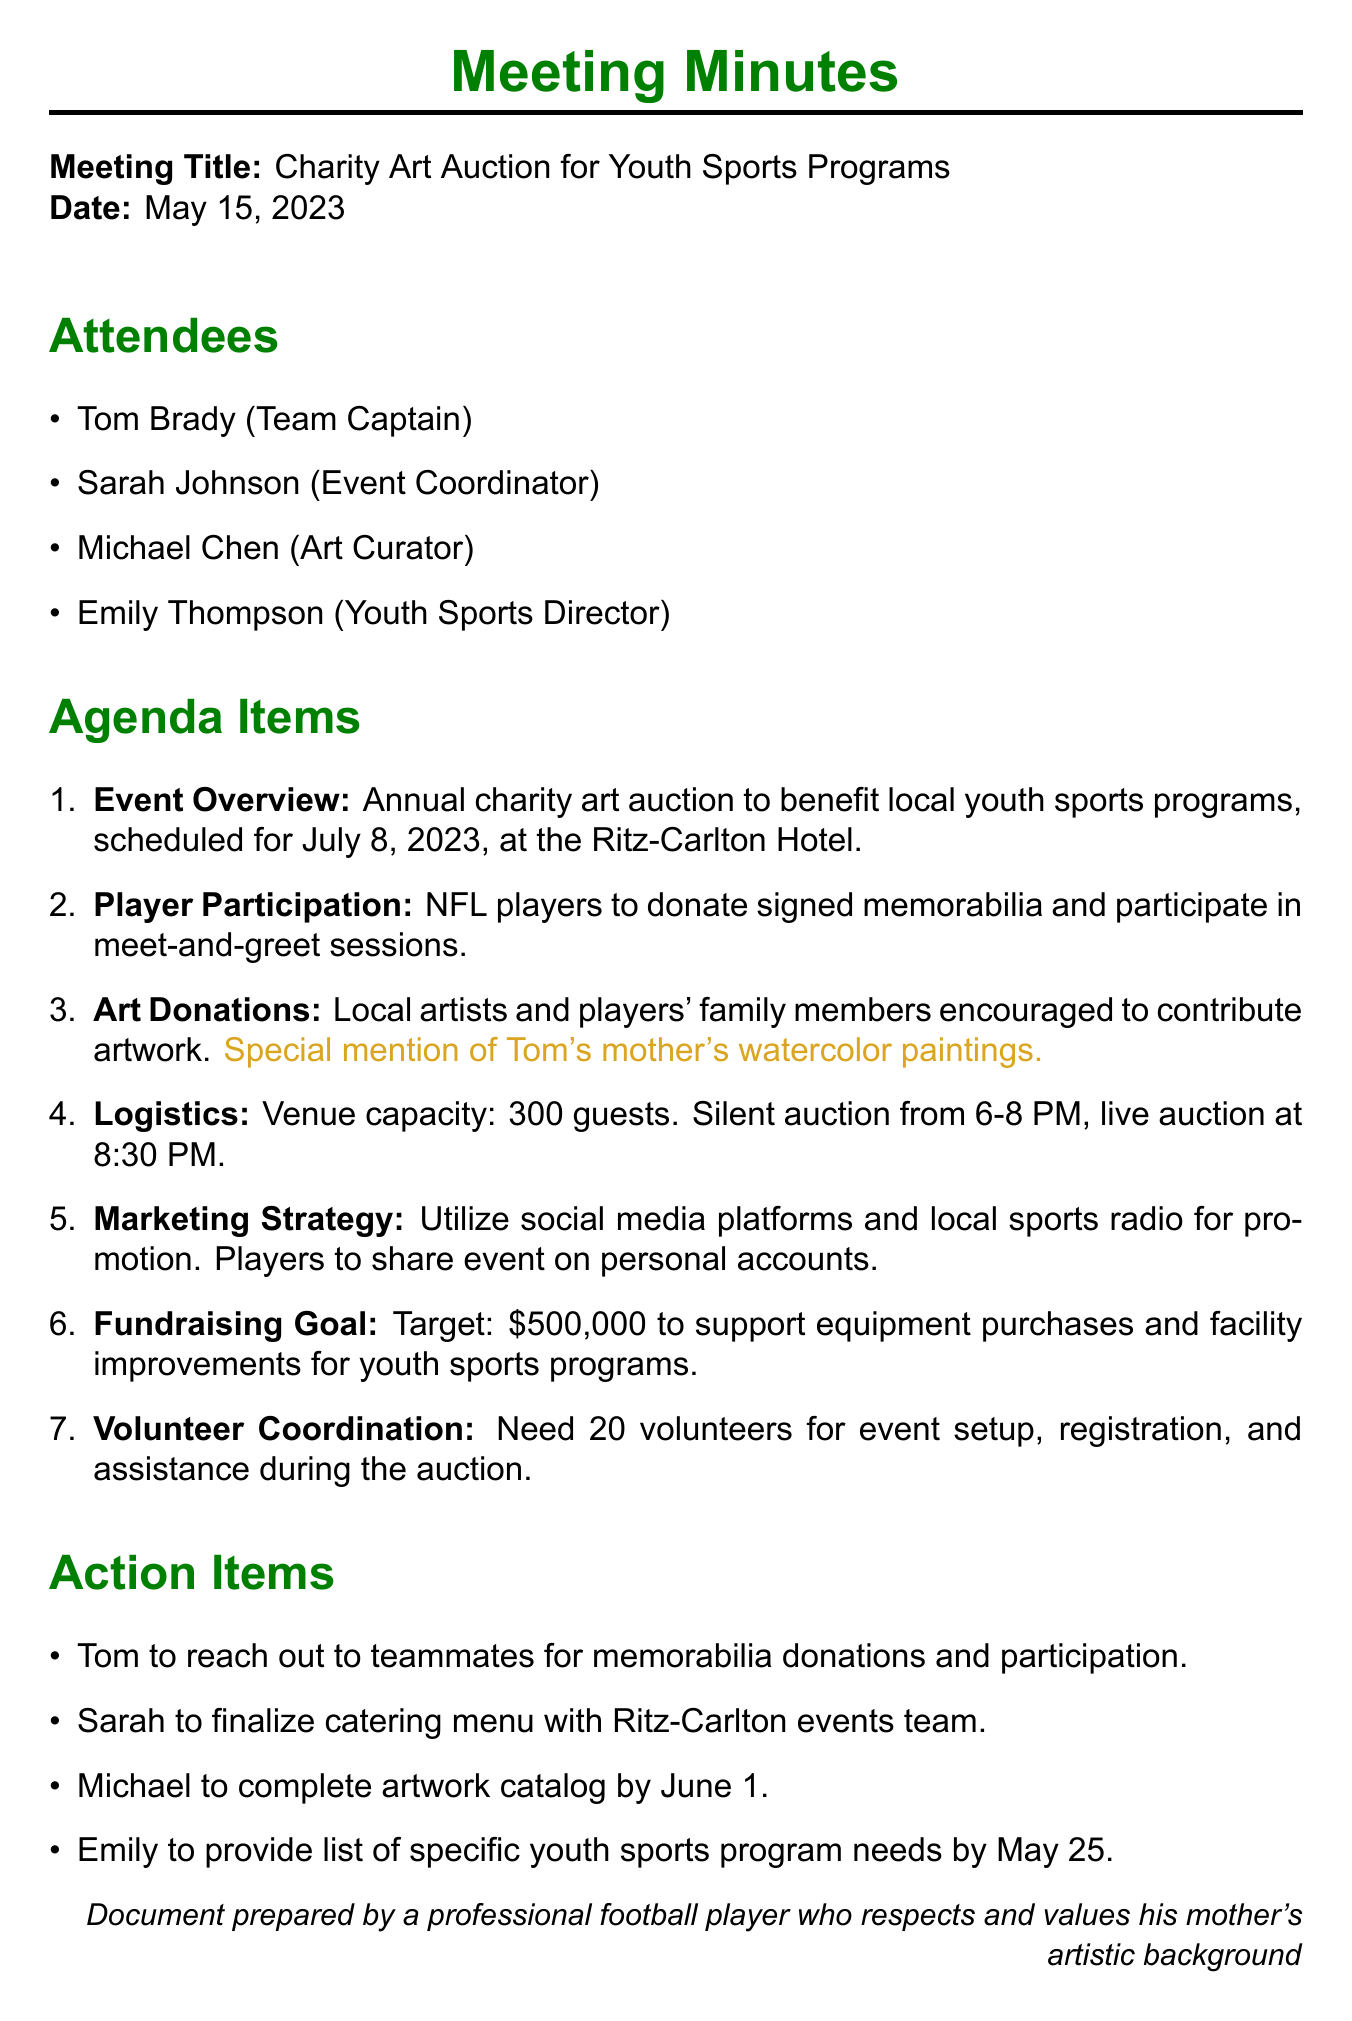What is the date of the meeting? The date of the meeting is specified in the document under the date header.
Answer: May 15, 2023 Where is the charity art auction scheduled to take place? The location of the charity art auction is outlined in the Event Overview section.
Answer: Ritz-Carlton Hotel What is the fundraising goal for the event? The target amount for fundraising is mentioned in the Fundraising Goal section.
Answer: $500,000 Who is coordinating the event? The person responsible for coordinating the event is listed in the Attendees section.
Answer: Sarah Johnson How many volunteers are needed for the event? The number of volunteers required is mentioned in the Volunteer Coordination section.
Answer: 20 What type of art is Tom's mother contributing? The type of artwork mentioned in relation to Tom's mother is stated in the Art Donations section.
Answer: Watercolor paintings What time does the silent auction start? The start time for the silent auction is provided in the Logistics section.
Answer: 6 PM What action item is assigned to Tom? The specific task for Tom is outlined in the Action Items section.
Answer: Reach out to teammates for memorabilia donations and participation 